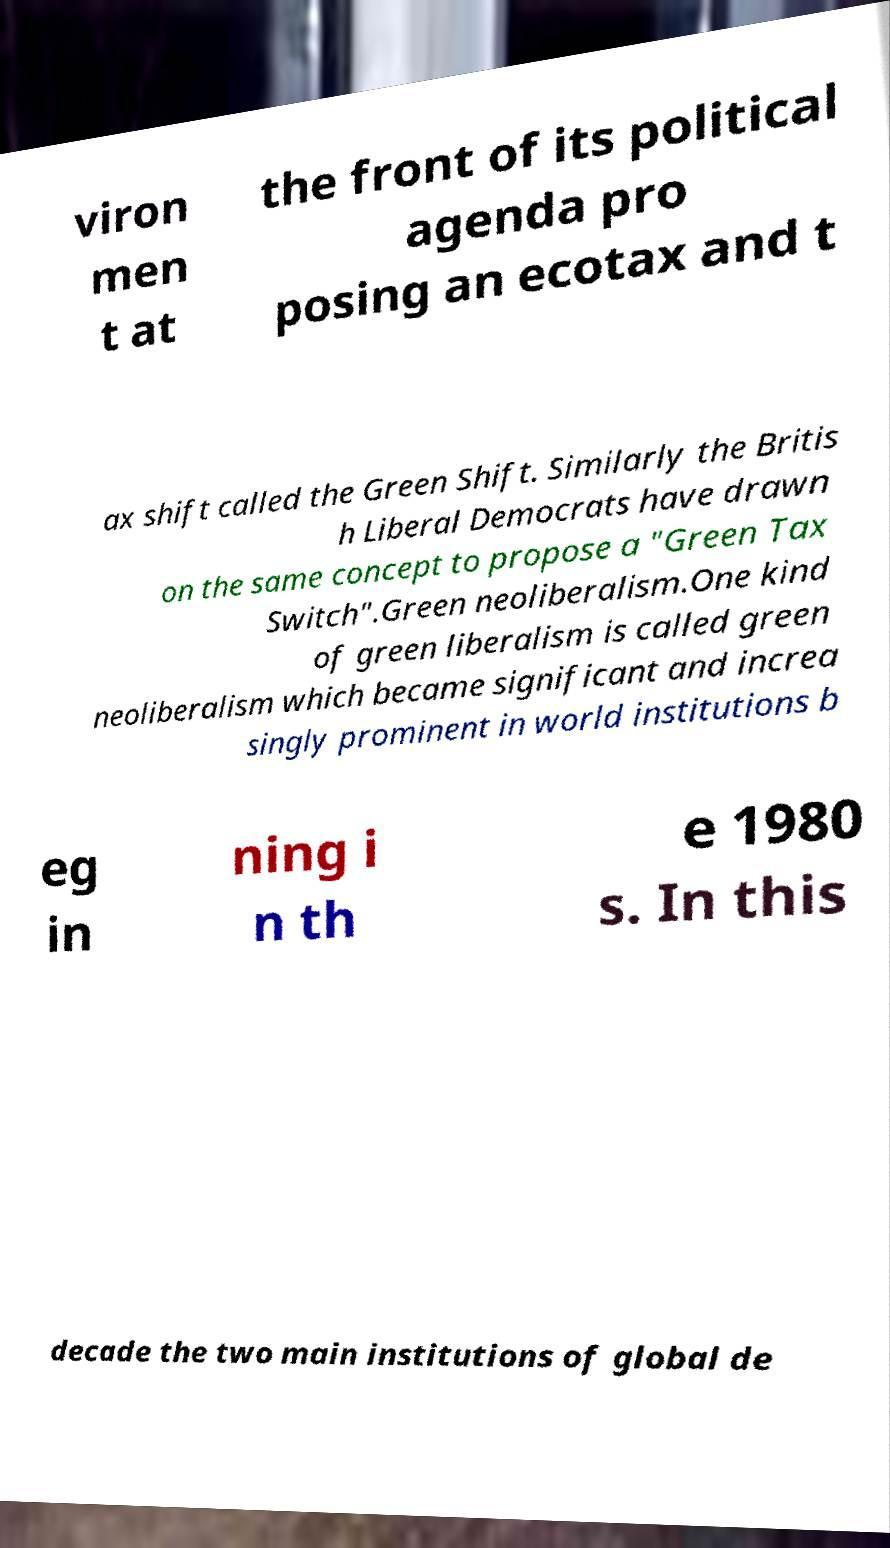Please identify and transcribe the text found in this image. viron men t at the front of its political agenda pro posing an ecotax and t ax shift called the Green Shift. Similarly the Britis h Liberal Democrats have drawn on the same concept to propose a "Green Tax Switch".Green neoliberalism.One kind of green liberalism is called green neoliberalism which became significant and increa singly prominent in world institutions b eg in ning i n th e 1980 s. In this decade the two main institutions of global de 